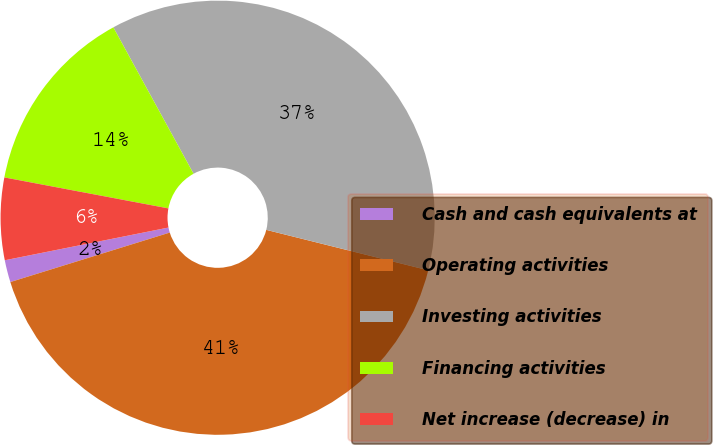Convert chart. <chart><loc_0><loc_0><loc_500><loc_500><pie_chart><fcel>Cash and cash equivalents at<fcel>Operating activities<fcel>Investing activities<fcel>Financing activities<fcel>Net increase (decrease) in<nl><fcel>1.65%<fcel>41.31%<fcel>36.87%<fcel>14.05%<fcel>6.11%<nl></chart> 